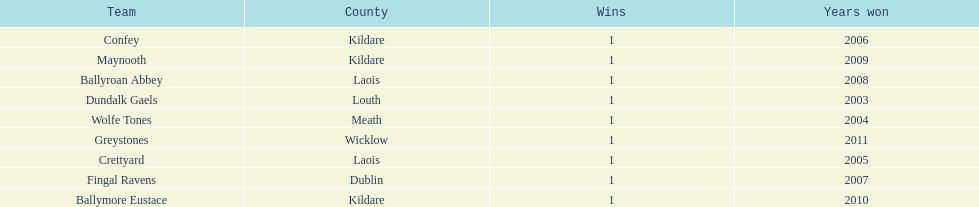Which team was the previous winner before ballyroan abbey in 2008? Fingal Ravens. 